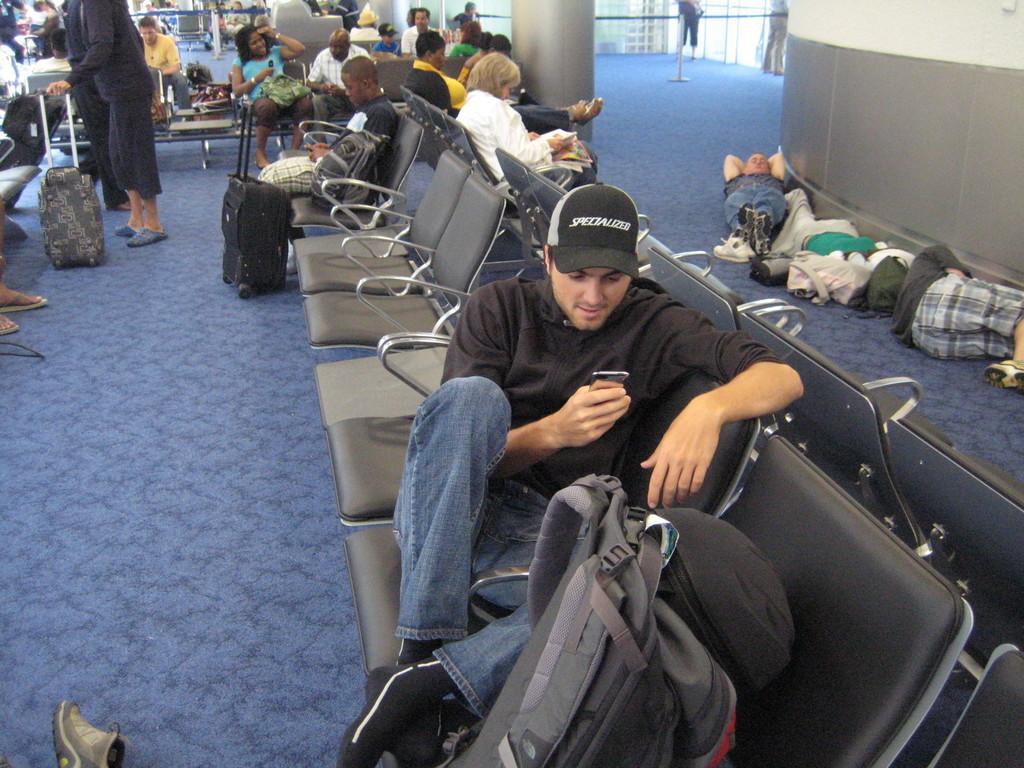Describe this image in one or two sentences. In this image we can see a man holding a mobile phone and sitting on the chair. There are bags in front of him. In the background we can see people sitting, standing and lying on the ground. 